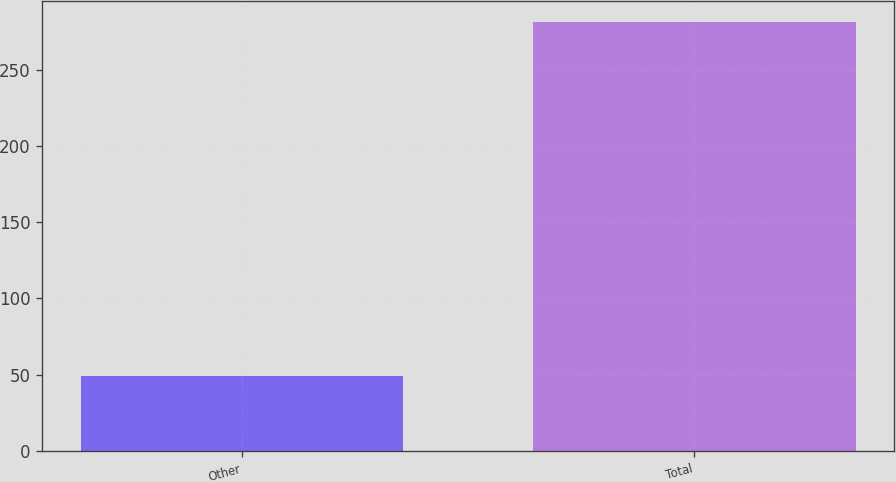<chart> <loc_0><loc_0><loc_500><loc_500><bar_chart><fcel>Other<fcel>Total<nl><fcel>49<fcel>281<nl></chart> 